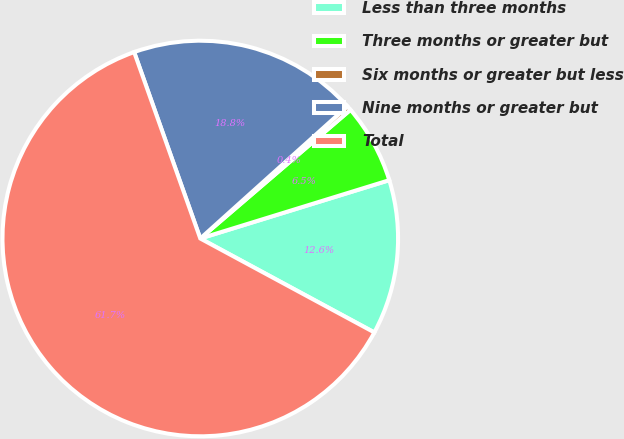<chart> <loc_0><loc_0><loc_500><loc_500><pie_chart><fcel>Less than three months<fcel>Three months or greater but<fcel>Six months or greater but less<fcel>Nine months or greater but<fcel>Total<nl><fcel>12.64%<fcel>6.51%<fcel>0.38%<fcel>18.77%<fcel>61.69%<nl></chart> 